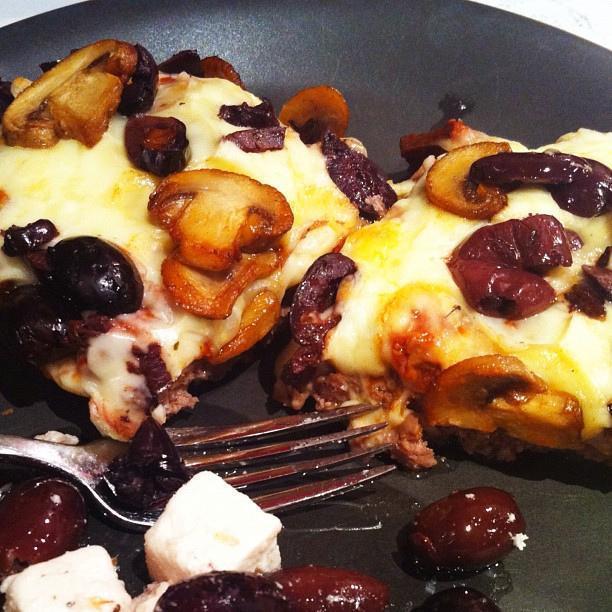How many forks are there?
Give a very brief answer. 1. How many sandwich on the plate?
Give a very brief answer. 0. 